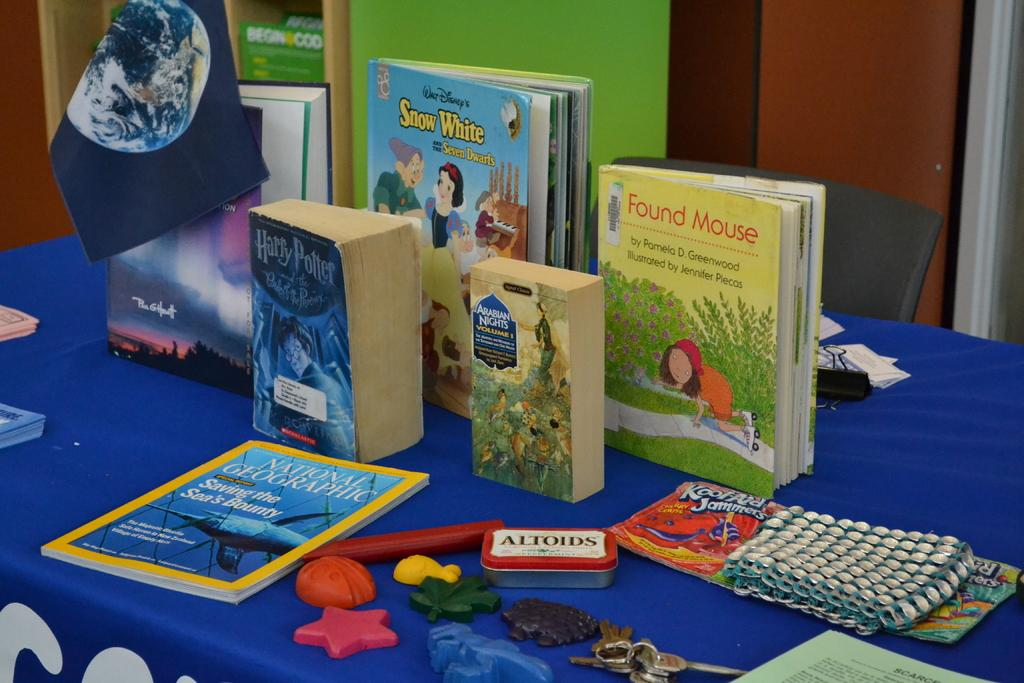<image>
Relay a brief, clear account of the picture shown. Several toys and books on a table including Walt Disney's Snow White and the Seven Dwarfs. 